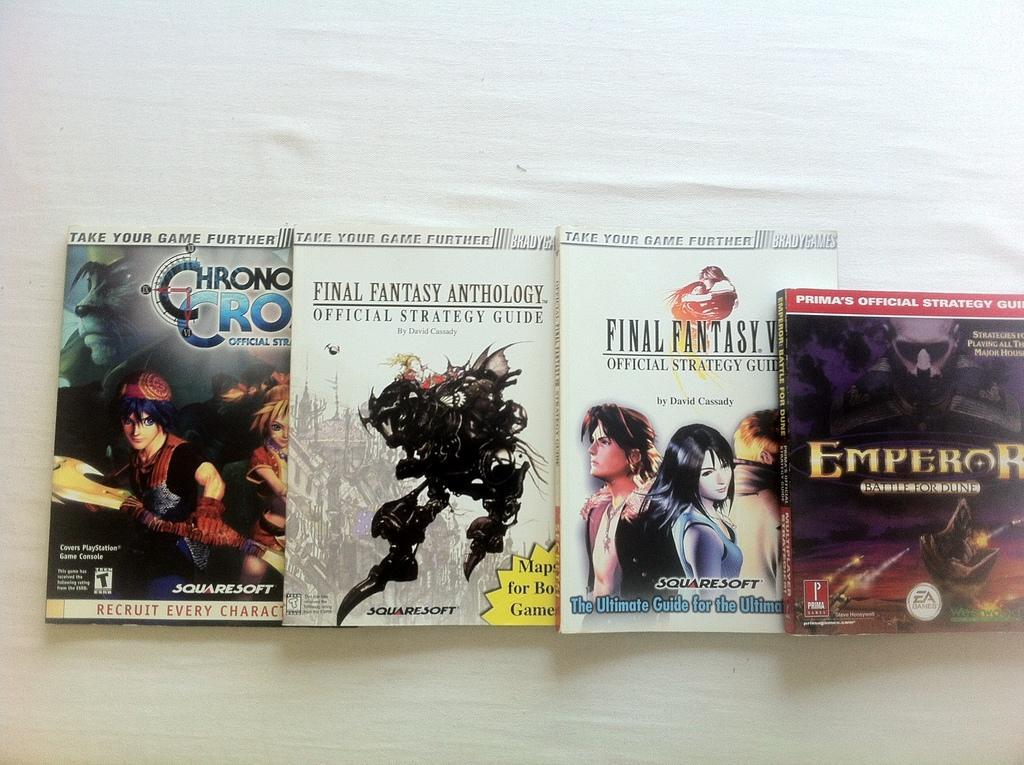Could you give a brief overview of what you see in this image? This picture consists of books and on top of books I can see text and cartoon image and books might be kept on white color table. 